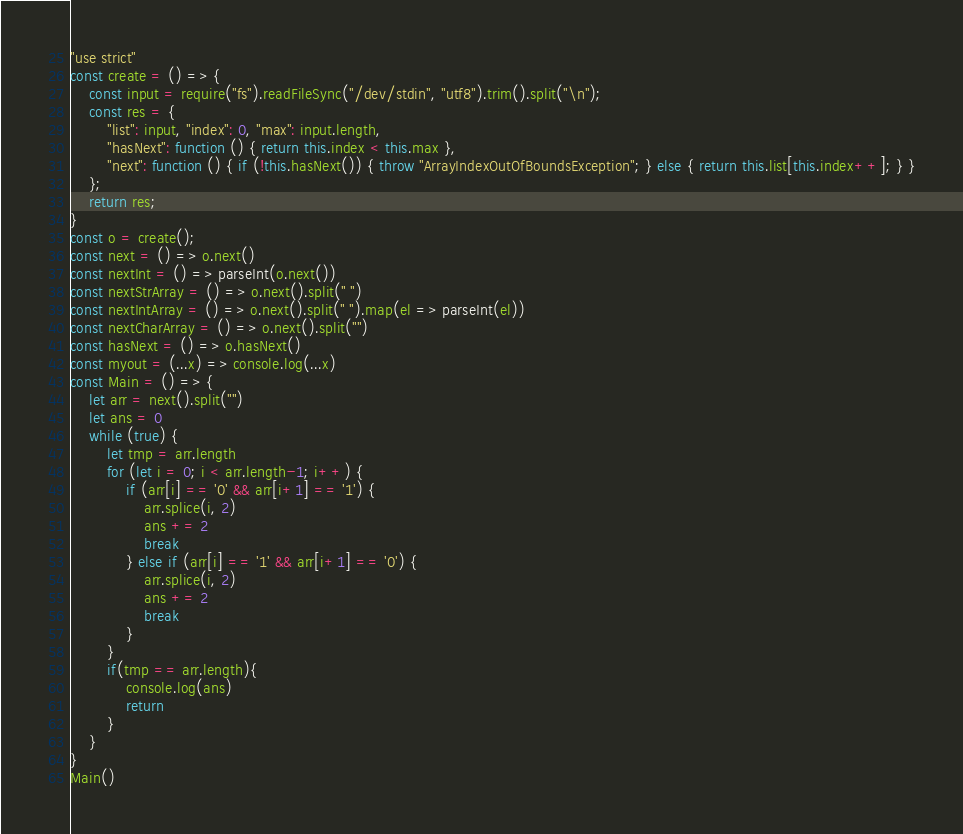Convert code to text. <code><loc_0><loc_0><loc_500><loc_500><_JavaScript_>"use strict"
const create = () => {
    const input = require("fs").readFileSync("/dev/stdin", "utf8").trim().split("\n");
    const res = {
        "list": input, "index": 0, "max": input.length,
        "hasNext": function () { return this.index < this.max },
        "next": function () { if (!this.hasNext()) { throw "ArrayIndexOutOfBoundsException"; } else { return this.list[this.index++]; } }
    };
    return res;
}
const o = create();
const next = () => o.next()
const nextInt = () => parseInt(o.next())
const nextStrArray = () => o.next().split(" ")
const nextIntArray = () => o.next().split(" ").map(el => parseInt(el))
const nextCharArray = () => o.next().split("")
const hasNext = () => o.hasNext()
const myout = (...x) => console.log(...x)
const Main = () => {
    let arr = next().split("")
    let ans = 0
    while (true) {
        let tmp = arr.length
        for (let i = 0; i < arr.length-1; i++) {
            if (arr[i] == '0' && arr[i+1] == '1') {
                arr.splice(i, 2)
                ans += 2
                break
            } else if (arr[i] == '1' && arr[i+1] == '0') {
                arr.splice(i, 2)
                ans += 2
                break
            }
        }
        if(tmp == arr.length){
            console.log(ans)
            return
        }
    }
}
Main()

</code> 